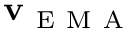<formula> <loc_0><loc_0><loc_500><loc_500>v _ { E M A }</formula> 